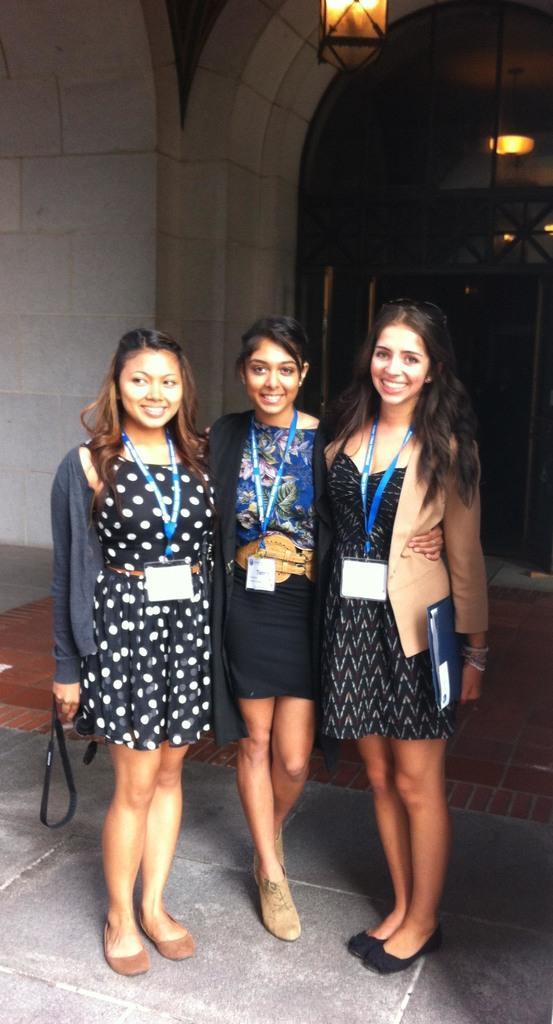Could you give a brief overview of what you see in this image? In this image we can see group of persons are standing, and smiling, they are wearing an id card, there are lights, there is a wall. 